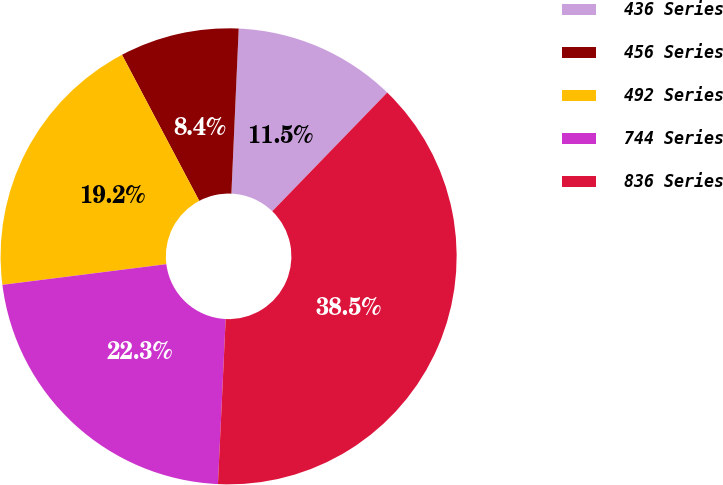Convert chart to OTSL. <chart><loc_0><loc_0><loc_500><loc_500><pie_chart><fcel>436 Series<fcel>456 Series<fcel>492 Series<fcel>744 Series<fcel>836 Series<nl><fcel>11.54%<fcel>8.45%<fcel>19.25%<fcel>22.26%<fcel>38.5%<nl></chart> 